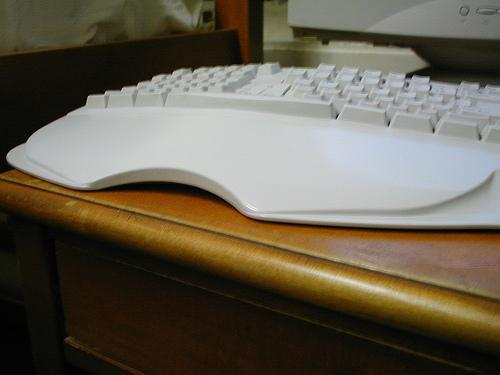Point out any imperfections found on the desk's surface. There is a stained top on the desk. Describe the computer monitor in the image and any notable features. The computer monitor is white, sitting on the desk, and has a small circular button and a line on it. What is the primary object on the desk as indicated by the image? A white keyboard on the desk Can you please identify what the main device on this desk is? The main device is a white computer keyboard. Identify any special keys or features that are mentioned for the keyboard itself. A long white spacebar and a curve on the bottom of the keyboard are mentioned. What is the color of the keyboard and the desk in the image? The keyboard is white, and the desk is light brown. Enumerate some objects found on the keyboard. Spacebar, wrist rest, curve on the bottom, and several keys can be found on the keyboard. Explain the material and appearance of the desk. The desk is made of light brown wood with a stained top. Give a brief overview of the image components focusing on the computer-related items. The image features a white keyboard and a white monitor on a light brown wooden desk. Count the number of keys on the key board that have been described individually. Nine keys have been described individually. 